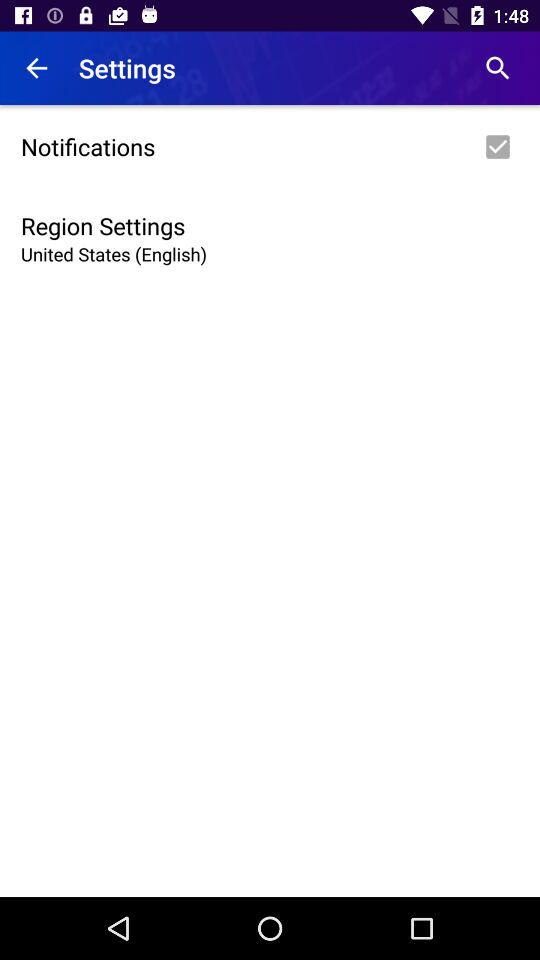Which region is selected? The selected region is the United States. 